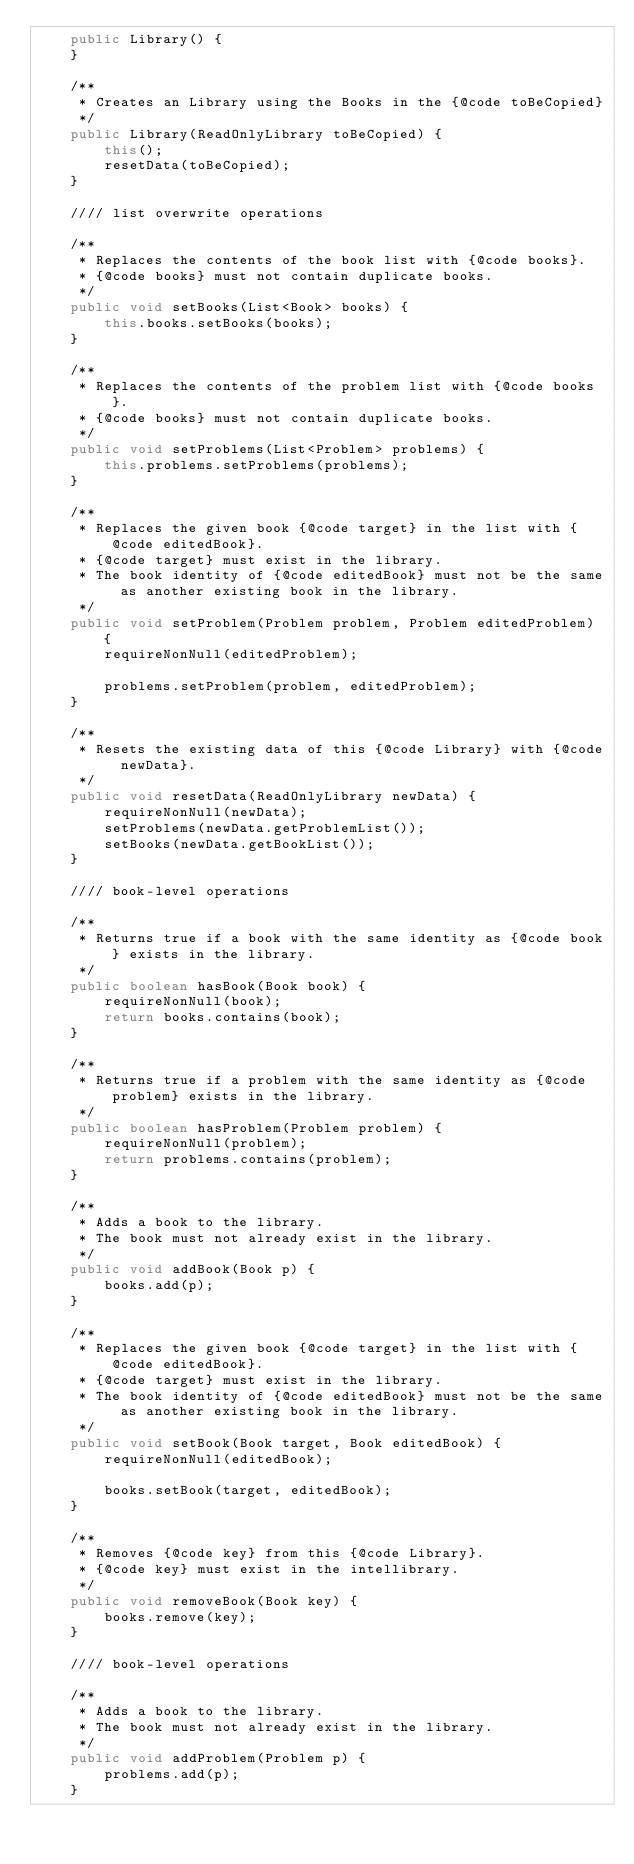Convert code to text. <code><loc_0><loc_0><loc_500><loc_500><_Java_>    public Library() {
    }

    /**
     * Creates an Library using the Books in the {@code toBeCopied}
     */
    public Library(ReadOnlyLibrary toBeCopied) {
        this();
        resetData(toBeCopied);
    }

    //// list overwrite operations

    /**
     * Replaces the contents of the book list with {@code books}.
     * {@code books} must not contain duplicate books.
     */
    public void setBooks(List<Book> books) {
        this.books.setBooks(books);
    }

    /**
     * Replaces the contents of the problem list with {@code books}.
     * {@code books} must not contain duplicate books.
     */
    public void setProblems(List<Problem> problems) {
        this.problems.setProblems(problems);
    }

    /**
     * Replaces the given book {@code target} in the list with {@code editedBook}.
     * {@code target} must exist in the library.
     * The book identity of {@code editedBook} must not be the same as another existing book in the library.
     */
    public void setProblem(Problem problem, Problem editedProblem) {
        requireNonNull(editedProblem);

        problems.setProblem(problem, editedProblem);
    }

    /**
     * Resets the existing data of this {@code Library} with {@code newData}.
     */
    public void resetData(ReadOnlyLibrary newData) {
        requireNonNull(newData);
        setProblems(newData.getProblemList());
        setBooks(newData.getBookList());
    }

    //// book-level operations

    /**
     * Returns true if a book with the same identity as {@code book} exists in the library.
     */
    public boolean hasBook(Book book) {
        requireNonNull(book);
        return books.contains(book);
    }

    /**
     * Returns true if a problem with the same identity as {@code problem} exists in the library.
     */
    public boolean hasProblem(Problem problem) {
        requireNonNull(problem);
        return problems.contains(problem);
    }

    /**
     * Adds a book to the library.
     * The book must not already exist in the library.
     */
    public void addBook(Book p) {
        books.add(p);
    }

    /**
     * Replaces the given book {@code target} in the list with {@code editedBook}.
     * {@code target} must exist in the library.
     * The book identity of {@code editedBook} must not be the same as another existing book in the library.
     */
    public void setBook(Book target, Book editedBook) {
        requireNonNull(editedBook);

        books.setBook(target, editedBook);
    }

    /**
     * Removes {@code key} from this {@code Library}.
     * {@code key} must exist in the intellibrary.
     */
    public void removeBook(Book key) {
        books.remove(key);
    }

    //// book-level operations

    /**
     * Adds a book to the library.
     * The book must not already exist in the library.
     */
    public void addProblem(Problem p) {
        problems.add(p);
    }
</code> 